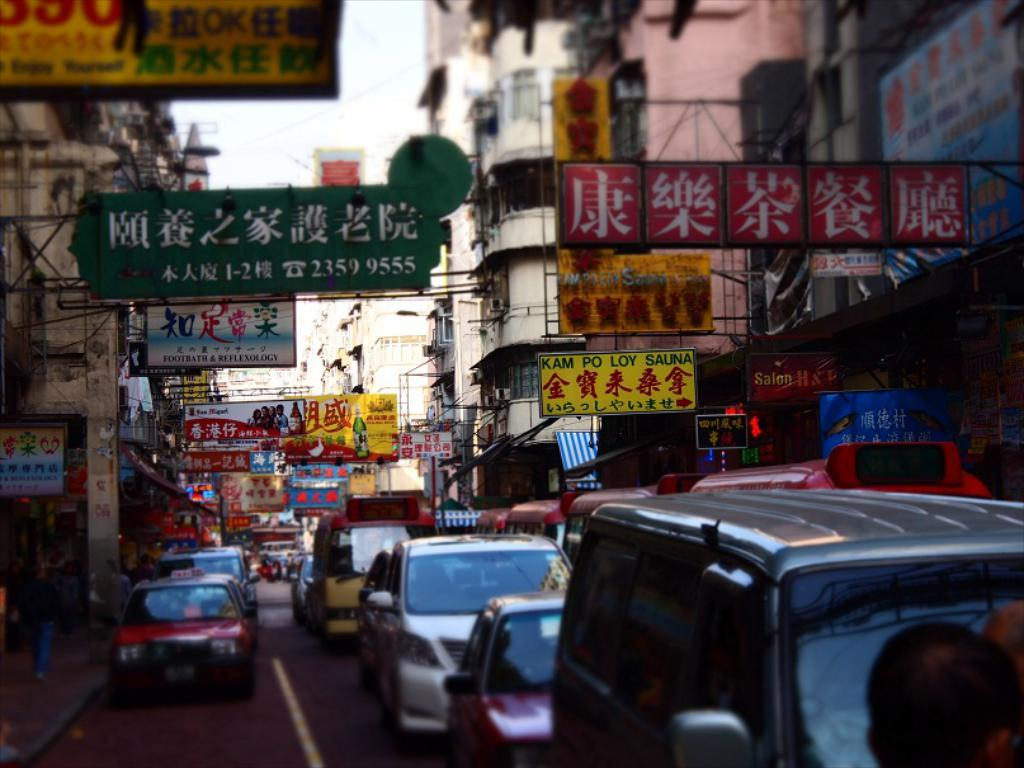<image>
Present a compact description of the photo's key features. A yellow sign for kam po loy sauna hangs over the sidewalk. 